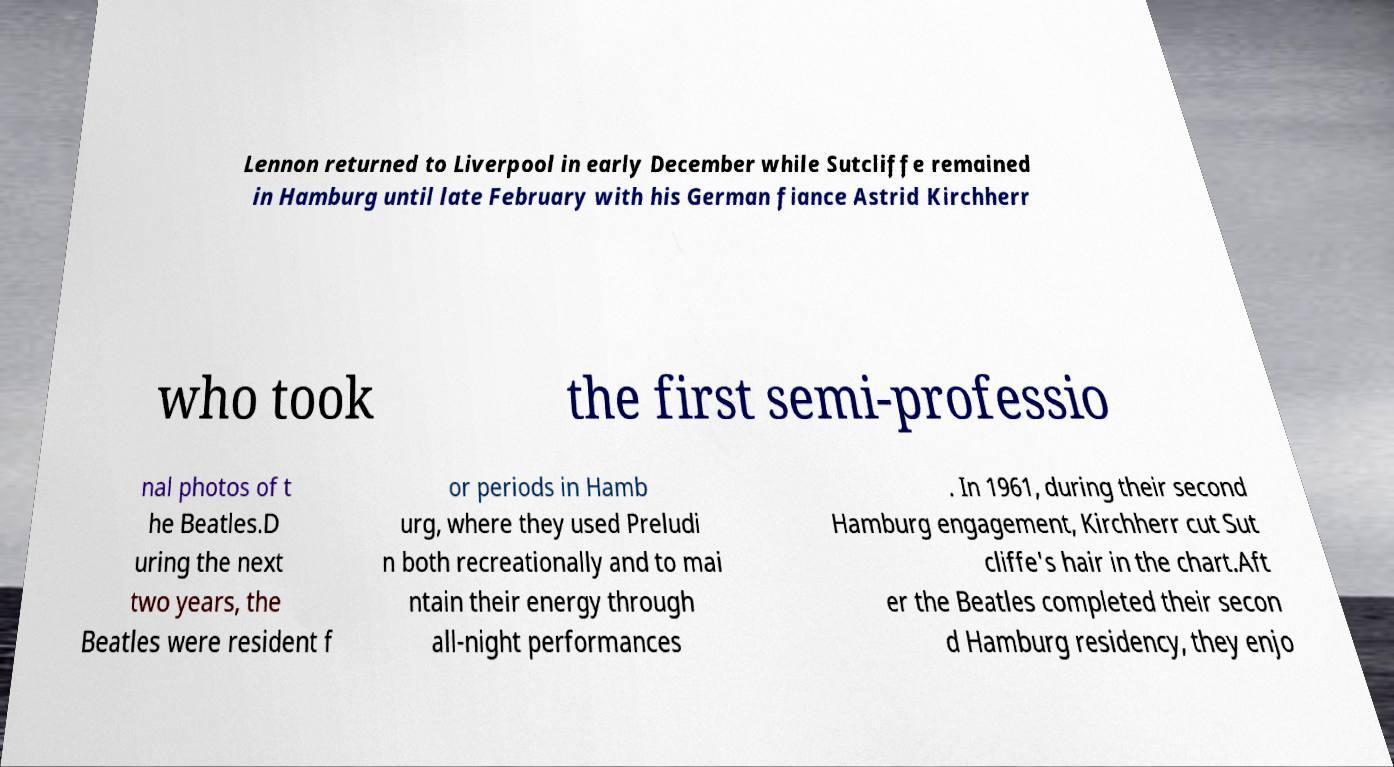There's text embedded in this image that I need extracted. Can you transcribe it verbatim? Lennon returned to Liverpool in early December while Sutcliffe remained in Hamburg until late February with his German fiance Astrid Kirchherr who took the first semi-professio nal photos of t he Beatles.D uring the next two years, the Beatles were resident f or periods in Hamb urg, where they used Preludi n both recreationally and to mai ntain their energy through all-night performances . In 1961, during their second Hamburg engagement, Kirchherr cut Sut cliffe's hair in the chart.Aft er the Beatles completed their secon d Hamburg residency, they enjo 